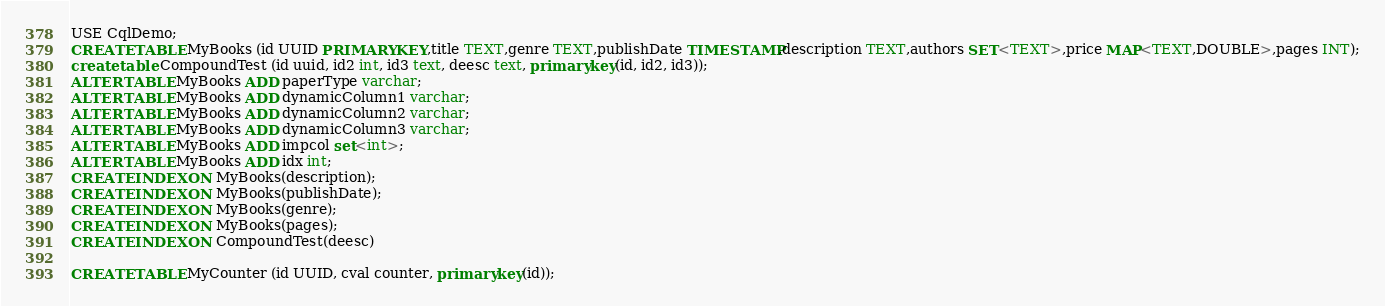Convert code to text. <code><loc_0><loc_0><loc_500><loc_500><_SQL_>USE CqlDemo;
CREATE TABLE MyBooks (id UUID PRIMARY KEY,title TEXT,genre TEXT,publishDate TIMESTAMP,description TEXT,authors SET<TEXT>,price MAP<TEXT,DOUBLE>,pages INT);
create table CompoundTest (id uuid, id2 int, id3 text, deesc text, primary key(id, id2, id3));
ALTER TABLE MyBooks ADD paperType varchar;
ALTER TABLE MyBooks ADD dynamicColumn1 varchar;
ALTER TABLE MyBooks ADD dynamicColumn2 varchar;
ALTER TABLE MyBooks ADD dynamicColumn3 varchar;
ALTER TABLE MyBooks ADD impcol set<int>;
ALTER TABLE MyBooks ADD idx int;
CREATE INDEX ON MyBooks(description);
CREATE INDEX ON MyBooks(publishDate);
CREATE INDEX ON MyBooks(genre);
CREATE INDEX ON MyBooks(pages);
CREATE INDEX ON CompoundTest(deesc)

CREATE TABLE MyCounter (id UUID, cval counter, primary key(id));</code> 